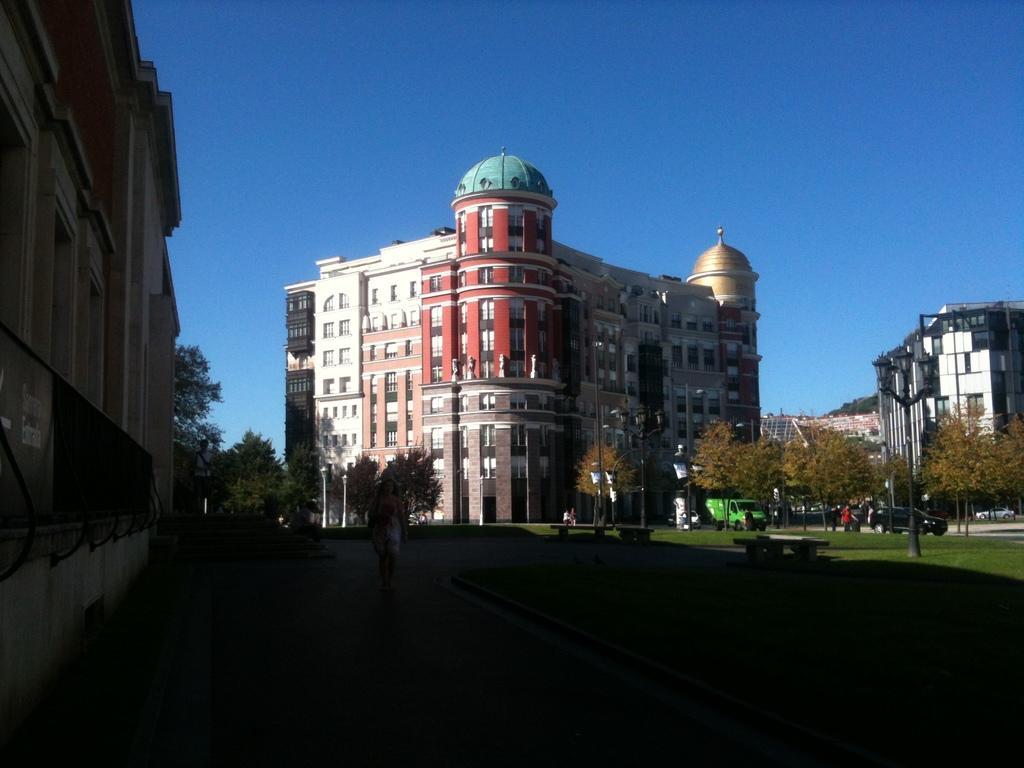Can you describe this image briefly? This image is taken outdoors. At the bottom of the image there is a ground with grass on it. On the left side of the image there is a building. In the middle of the image there are a few buildings with walls, windows, doors, railings, balconies and roofs. There are a few trees on the ground. A few vehicles are parked on the road and there are a few poles with street lights. At the top of the image there is a sky. 